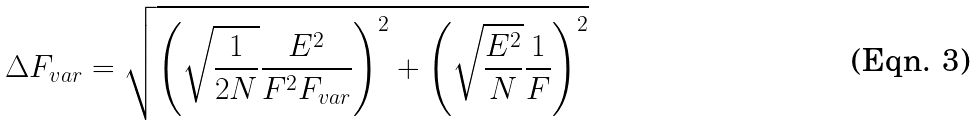<formula> <loc_0><loc_0><loc_500><loc_500>\Delta F _ { v a r } = \sqrt { \left ( \sqrt { \frac { 1 } { 2 N } } \frac { E ^ { 2 } } { F ^ { 2 } F _ { v a r } } \right ) ^ { 2 } + \left ( \sqrt { \frac { E ^ { 2 } } { N } } \frac { 1 } { F } \right ) ^ { 2 } }</formula> 